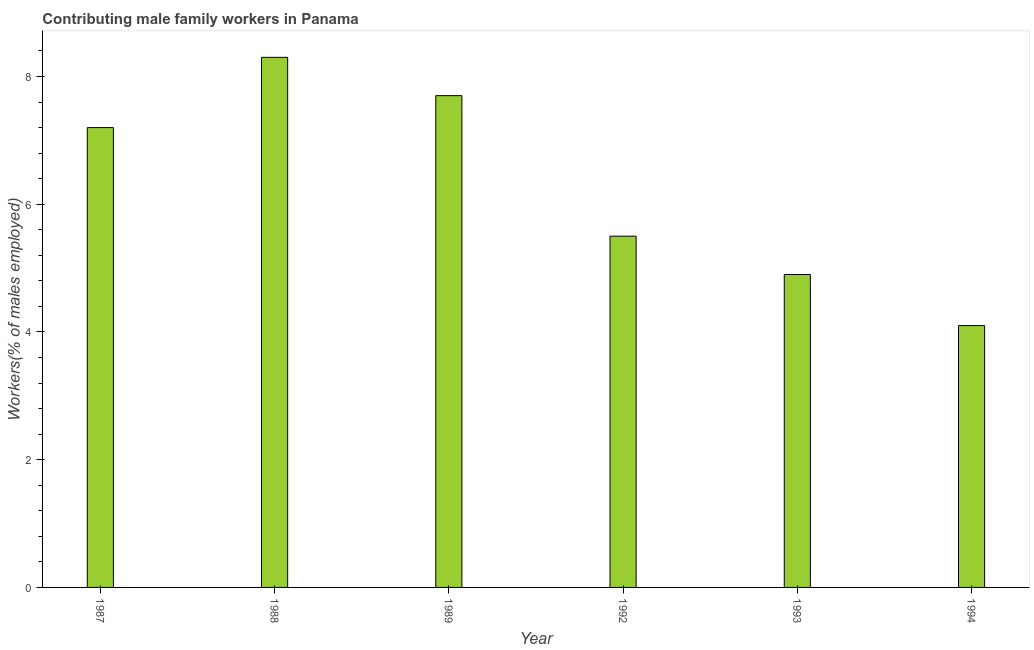Does the graph contain grids?
Keep it short and to the point. No. What is the title of the graph?
Keep it short and to the point. Contributing male family workers in Panama. What is the label or title of the Y-axis?
Make the answer very short. Workers(% of males employed). What is the contributing male family workers in 1987?
Provide a succinct answer. 7.2. Across all years, what is the maximum contributing male family workers?
Make the answer very short. 8.3. Across all years, what is the minimum contributing male family workers?
Your answer should be compact. 4.1. In which year was the contributing male family workers maximum?
Your response must be concise. 1988. What is the sum of the contributing male family workers?
Your response must be concise. 37.7. What is the difference between the contributing male family workers in 1992 and 1993?
Keep it short and to the point. 0.6. What is the average contributing male family workers per year?
Your response must be concise. 6.28. What is the median contributing male family workers?
Ensure brevity in your answer.  6.35. In how many years, is the contributing male family workers greater than 7.2 %?
Offer a terse response. 2. What is the ratio of the contributing male family workers in 1989 to that in 1994?
Offer a very short reply. 1.88. Is the contributing male family workers in 1987 less than that in 1993?
Provide a succinct answer. No. Is the difference between the contributing male family workers in 1988 and 1993 greater than the difference between any two years?
Provide a succinct answer. No. What is the difference between the highest and the second highest contributing male family workers?
Make the answer very short. 0.6. What is the difference between the highest and the lowest contributing male family workers?
Your answer should be very brief. 4.2. What is the difference between two consecutive major ticks on the Y-axis?
Give a very brief answer. 2. What is the Workers(% of males employed) in 1987?
Make the answer very short. 7.2. What is the Workers(% of males employed) in 1988?
Keep it short and to the point. 8.3. What is the Workers(% of males employed) of 1989?
Your answer should be very brief. 7.7. What is the Workers(% of males employed) in 1992?
Provide a short and direct response. 5.5. What is the Workers(% of males employed) of 1993?
Offer a terse response. 4.9. What is the Workers(% of males employed) of 1994?
Provide a short and direct response. 4.1. What is the difference between the Workers(% of males employed) in 1987 and 1988?
Your answer should be very brief. -1.1. What is the difference between the Workers(% of males employed) in 1987 and 1993?
Make the answer very short. 2.3. What is the difference between the Workers(% of males employed) in 1988 and 1989?
Provide a short and direct response. 0.6. What is the difference between the Workers(% of males employed) in 1988 and 1992?
Make the answer very short. 2.8. What is the difference between the Workers(% of males employed) in 1988 and 1993?
Provide a short and direct response. 3.4. What is the difference between the Workers(% of males employed) in 1989 and 1992?
Your response must be concise. 2.2. What is the difference between the Workers(% of males employed) in 1992 and 1994?
Your answer should be compact. 1.4. What is the ratio of the Workers(% of males employed) in 1987 to that in 1988?
Give a very brief answer. 0.87. What is the ratio of the Workers(% of males employed) in 1987 to that in 1989?
Give a very brief answer. 0.94. What is the ratio of the Workers(% of males employed) in 1987 to that in 1992?
Give a very brief answer. 1.31. What is the ratio of the Workers(% of males employed) in 1987 to that in 1993?
Ensure brevity in your answer.  1.47. What is the ratio of the Workers(% of males employed) in 1987 to that in 1994?
Offer a very short reply. 1.76. What is the ratio of the Workers(% of males employed) in 1988 to that in 1989?
Offer a terse response. 1.08. What is the ratio of the Workers(% of males employed) in 1988 to that in 1992?
Provide a succinct answer. 1.51. What is the ratio of the Workers(% of males employed) in 1988 to that in 1993?
Ensure brevity in your answer.  1.69. What is the ratio of the Workers(% of males employed) in 1988 to that in 1994?
Give a very brief answer. 2.02. What is the ratio of the Workers(% of males employed) in 1989 to that in 1993?
Offer a very short reply. 1.57. What is the ratio of the Workers(% of males employed) in 1989 to that in 1994?
Offer a very short reply. 1.88. What is the ratio of the Workers(% of males employed) in 1992 to that in 1993?
Offer a very short reply. 1.12. What is the ratio of the Workers(% of males employed) in 1992 to that in 1994?
Offer a terse response. 1.34. What is the ratio of the Workers(% of males employed) in 1993 to that in 1994?
Keep it short and to the point. 1.2. 